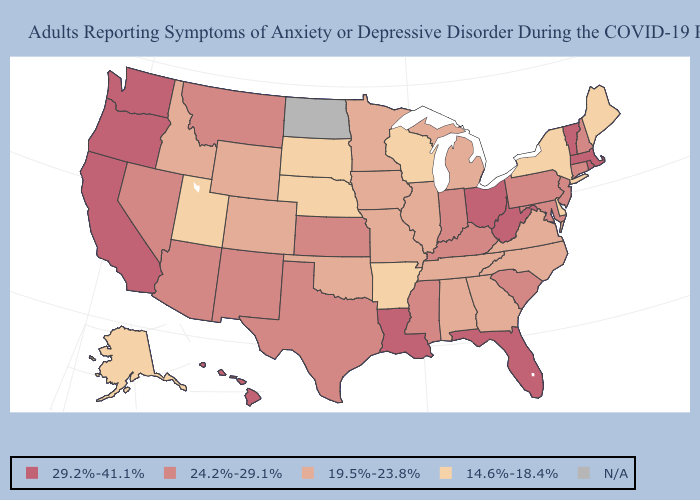Is the legend a continuous bar?
Concise answer only. No. What is the value of South Dakota?
Answer briefly. 14.6%-18.4%. What is the value of Alabama?
Give a very brief answer. 19.5%-23.8%. Among the states that border North Carolina , which have the lowest value?
Short answer required. Georgia, Tennessee, Virginia. Which states have the lowest value in the MidWest?
Keep it brief. Nebraska, South Dakota, Wisconsin. Name the states that have a value in the range 14.6%-18.4%?
Short answer required. Alaska, Arkansas, Delaware, Maine, Nebraska, New York, South Dakota, Utah, Wisconsin. Among the states that border Kansas , which have the highest value?
Be succinct. Colorado, Missouri, Oklahoma. What is the value of Tennessee?
Give a very brief answer. 19.5%-23.8%. Which states have the highest value in the USA?
Short answer required. California, Florida, Hawaii, Louisiana, Massachusetts, Ohio, Oregon, Rhode Island, Vermont, Washington, West Virginia. What is the highest value in the West ?
Answer briefly. 29.2%-41.1%. What is the value of Virginia?
Give a very brief answer. 19.5%-23.8%. Does Arkansas have the lowest value in the South?
Write a very short answer. Yes. Which states have the lowest value in the USA?
Quick response, please. Alaska, Arkansas, Delaware, Maine, Nebraska, New York, South Dakota, Utah, Wisconsin. What is the highest value in the USA?
Quick response, please. 29.2%-41.1%. What is the value of South Dakota?
Keep it brief. 14.6%-18.4%. 